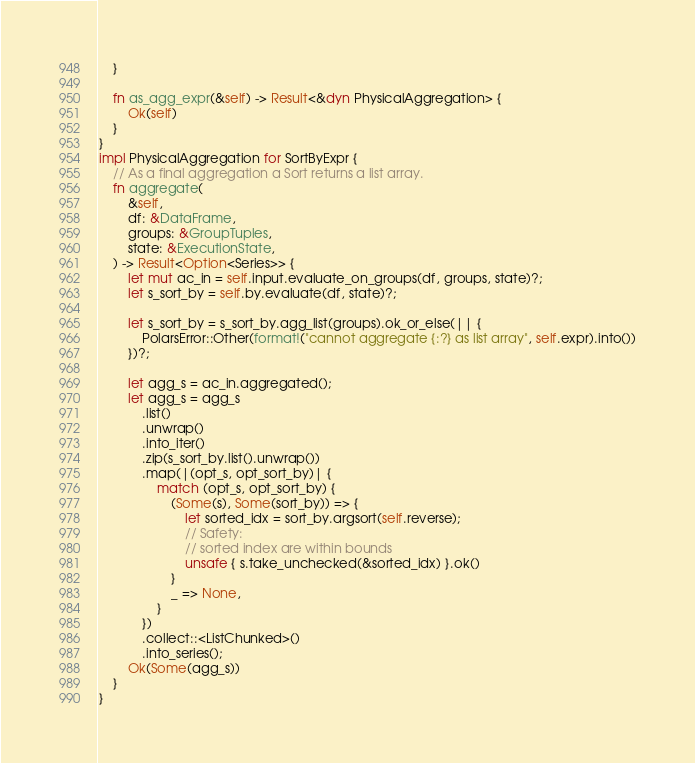Convert code to text. <code><loc_0><loc_0><loc_500><loc_500><_Rust_>    }

    fn as_agg_expr(&self) -> Result<&dyn PhysicalAggregation> {
        Ok(self)
    }
}
impl PhysicalAggregation for SortByExpr {
    // As a final aggregation a Sort returns a list array.
    fn aggregate(
        &self,
        df: &DataFrame,
        groups: &GroupTuples,
        state: &ExecutionState,
    ) -> Result<Option<Series>> {
        let mut ac_in = self.input.evaluate_on_groups(df, groups, state)?;
        let s_sort_by = self.by.evaluate(df, state)?;

        let s_sort_by = s_sort_by.agg_list(groups).ok_or_else(|| {
            PolarsError::Other(format!("cannot aggregate {:?} as list array", self.expr).into())
        })?;

        let agg_s = ac_in.aggregated();
        let agg_s = agg_s
            .list()
            .unwrap()
            .into_iter()
            .zip(s_sort_by.list().unwrap())
            .map(|(opt_s, opt_sort_by)| {
                match (opt_s, opt_sort_by) {
                    (Some(s), Some(sort_by)) => {
                        let sorted_idx = sort_by.argsort(self.reverse);
                        // Safety:
                        // sorted index are within bounds
                        unsafe { s.take_unchecked(&sorted_idx) }.ok()
                    }
                    _ => None,
                }
            })
            .collect::<ListChunked>()
            .into_series();
        Ok(Some(agg_s))
    }
}
</code> 